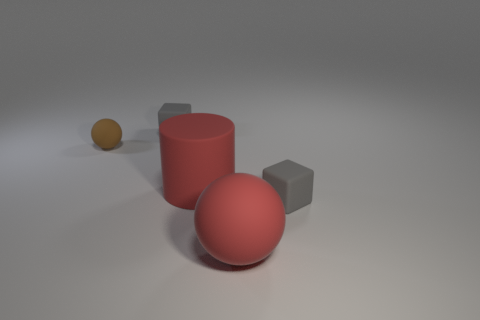The tiny thing in front of the matte cylinder is what color?
Keep it short and to the point. Gray. There is a matte object that is both behind the big rubber cylinder and to the right of the tiny sphere; how big is it?
Ensure brevity in your answer.  Small. What number of red matte objects are the same size as the red rubber cylinder?
Provide a short and direct response. 1. What number of large rubber objects are behind the tiny brown object?
Keep it short and to the point. 0. What shape is the gray matte object on the right side of the big thing behind the red ball?
Provide a succinct answer. Cube. There is a tiny brown object that is the same material as the large ball; what is its shape?
Provide a succinct answer. Sphere. There is a rubber cube that is behind the brown rubber sphere; does it have the same size as the red object to the left of the large red rubber sphere?
Make the answer very short. No. There is a small rubber thing on the right side of the red cylinder; what is its shape?
Offer a terse response. Cube. What is the color of the large cylinder?
Keep it short and to the point. Red. There is a brown object; is its size the same as the ball that is on the right side of the red cylinder?
Your response must be concise. No. 